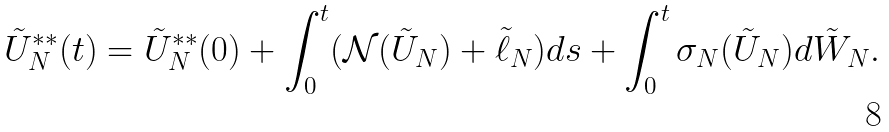Convert formula to latex. <formula><loc_0><loc_0><loc_500><loc_500>\tilde { U } ^ { * * } _ { N } ( t ) & = \tilde { U } ^ { * * } _ { N } ( 0 ) + \int _ { 0 } ^ { t } ( \mathcal { N } ( \tilde { U } _ { N } ) + \tilde { \ell } _ { N } ) d s + \int _ { 0 } ^ { t } \sigma _ { N } ( \tilde { U } _ { N } ) d \tilde { W } _ { N } .</formula> 